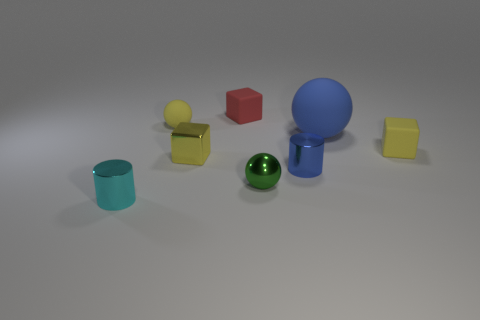The small cube that is the same material as the green ball is what color?
Offer a very short reply. Yellow. There is a object that is the same color as the big ball; what is its shape?
Give a very brief answer. Cylinder. Are there the same number of blue shiny cylinders to the left of the tiny cyan thing and tiny shiny cylinders right of the green ball?
Provide a short and direct response. No. There is a tiny thing that is to the left of the yellow thing that is behind the blue rubber ball; what is its shape?
Your response must be concise. Cylinder. There is a small blue object that is the same shape as the small cyan object; what is it made of?
Offer a very short reply. Metal. What is the color of the metallic ball that is the same size as the yellow shiny block?
Provide a short and direct response. Green. Is the number of tiny matte cubes that are behind the large ball the same as the number of tiny cylinders?
Keep it short and to the point. No. The cylinder that is to the left of the tiny metal cylinder that is on the right side of the small cyan shiny cylinder is what color?
Provide a succinct answer. Cyan. What is the size of the blue object that is in front of the yellow rubber object that is on the right side of the green metallic sphere?
Give a very brief answer. Small. What is the size of the rubber cube that is the same color as the shiny block?
Ensure brevity in your answer.  Small. 